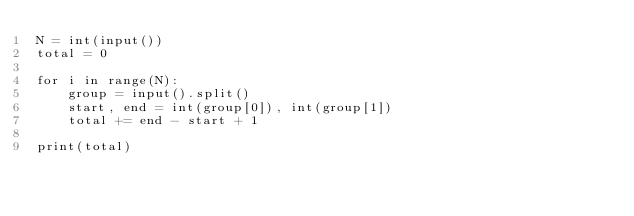<code> <loc_0><loc_0><loc_500><loc_500><_Python_>N = int(input())
total = 0

for i in range(N):
    group = input().split()
    start, end = int(group[0]), int(group[1])
    total += end - start + 1

print(total)</code> 